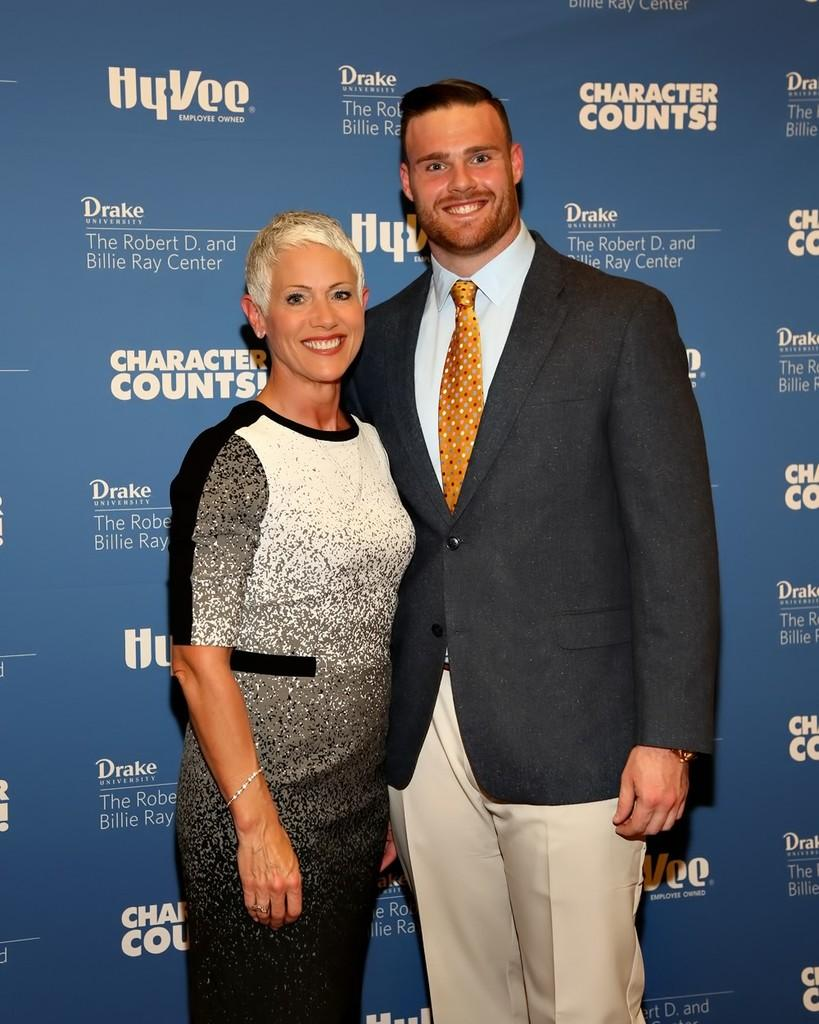How many people are present in the image? There are two people in the image, a man and a woman. What are the man and woman doing in the image? Both the man and woman are standing and smiling. What can be seen in the background of the image? There is a banner visible in the background of the image. What type of bait is the woman holding in the image? There is no bait present in the image; the woman is not holding anything. Can you hear the voice of the man in the image? The image is a still photograph, so there is no sound or voice present. 